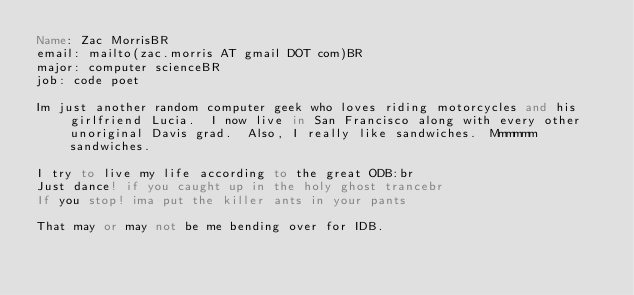<code> <loc_0><loc_0><loc_500><loc_500><_FORTRAN_>Name: Zac MorrisBR
email: mailto(zac.morris AT gmail DOT com)BR
major: computer scienceBR
job: code poet

Im just another random computer geek who loves riding motorcycles and his girlfriend Lucia.  I now live in San Francisco along with every other unoriginal Davis grad.  Also, I really like sandwiches.  Mmmmmm sandwiches.

I try to live my life according to the great ODB:br
Just dance! if you caught up in the holy ghost trancebr
If you stop! ima put the killer ants in your pants

That may or may not be me bending over for IDB.
</code> 